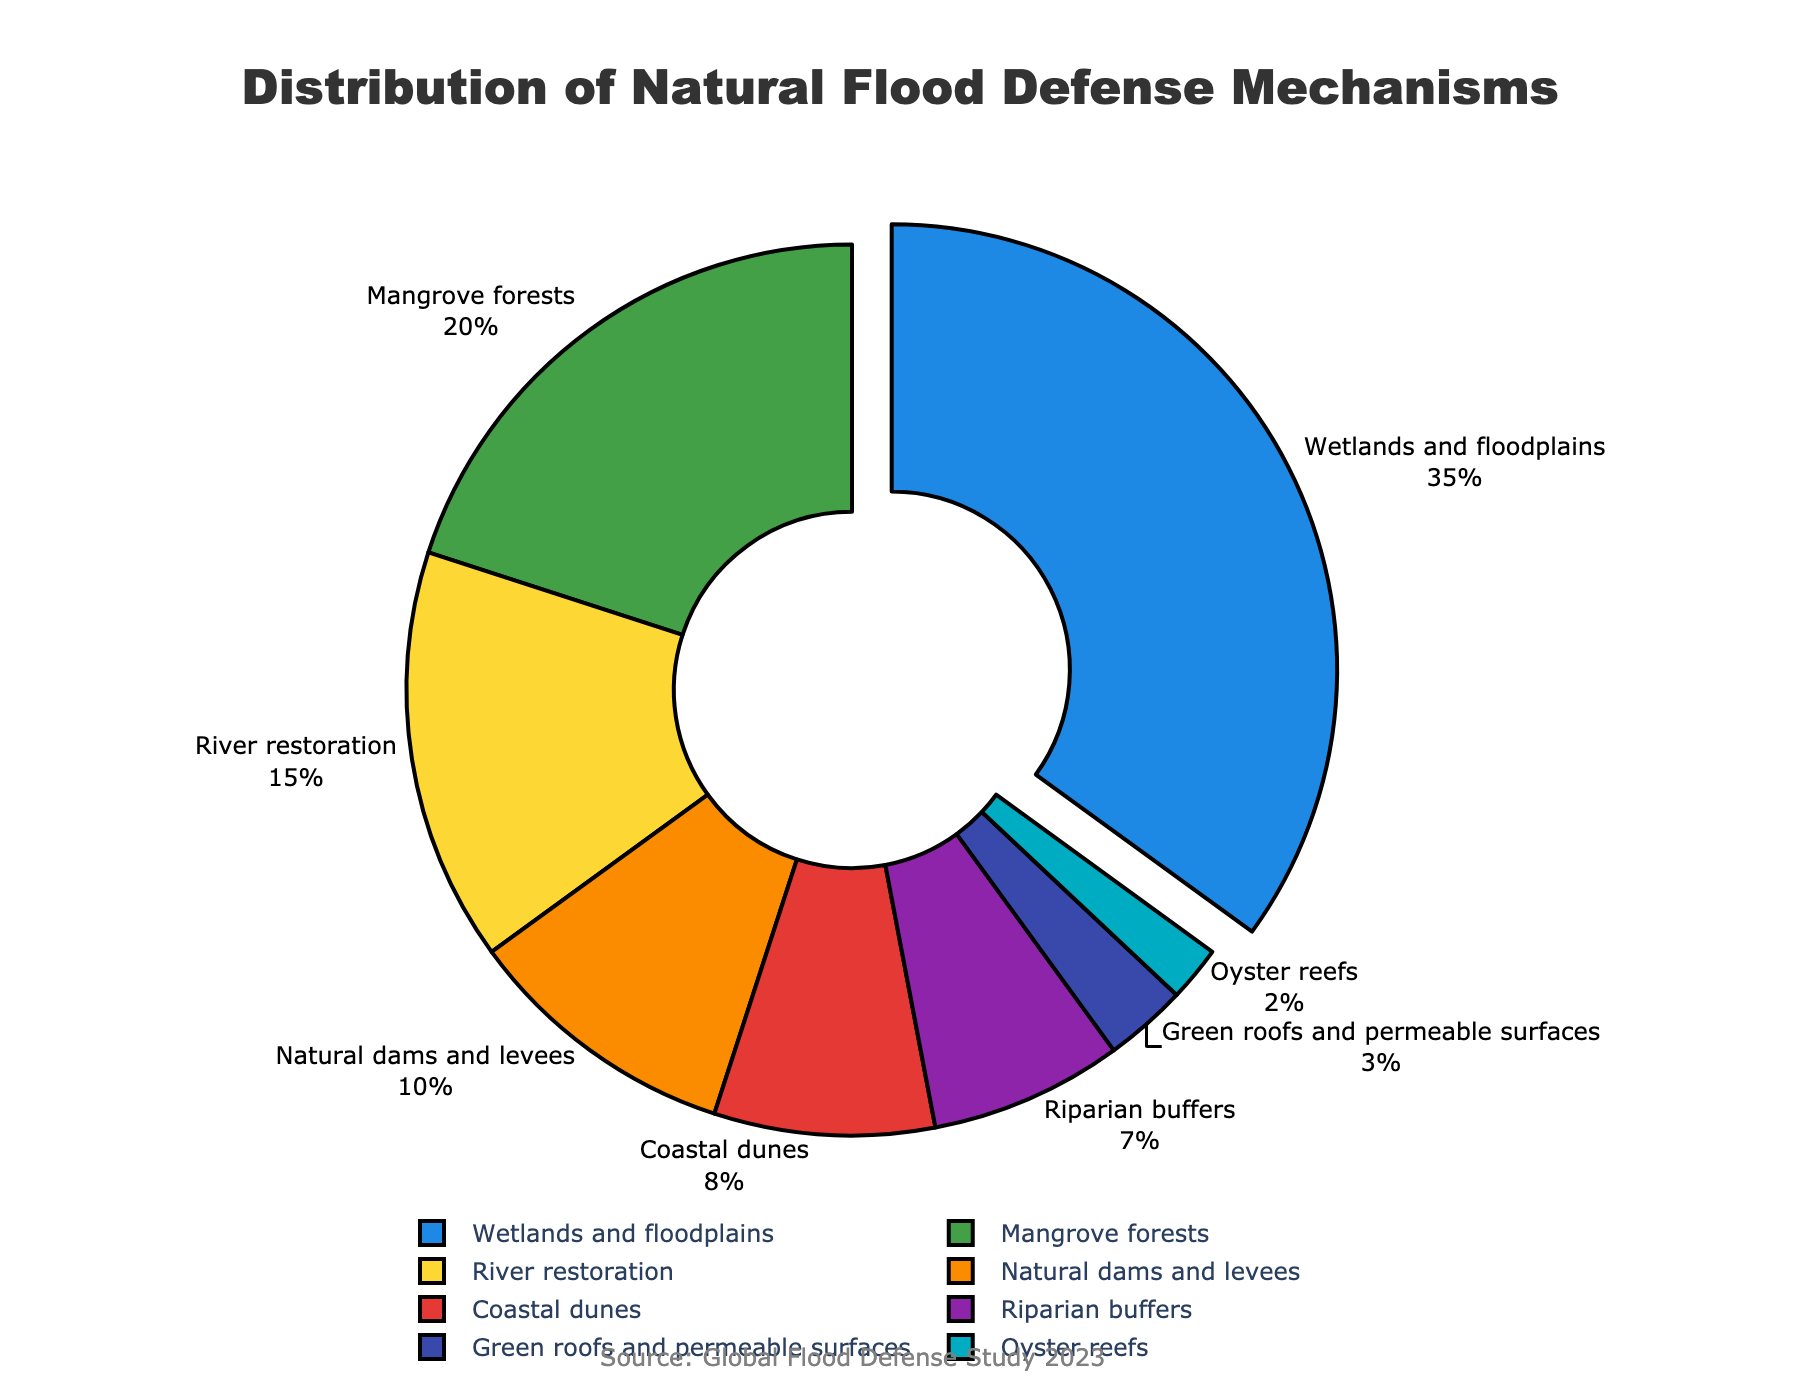Which natural flood defense mechanism is the most commonly used globally? The figure indicates the distribution of various natural flood defense mechanisms. By observing the largest segment in the pie chart, we can see that "Wetlands and floodplains" cover the largest proportion at 35%.
Answer: Wetlands and floodplains Which two categories have the closest percentage of usage? By comparing all the segments, the closest percentages are "Natural dams and levees" at 10% and "Coastal dunes" at 8%, showing the least difference.
Answer: Natural dams and levees and Coastal dunes What is the combined percentage of Mangrove forests, River restoration, and Oyster reefs? Adding the individual percentages of Mangrove forests (20%), River restoration (15%), and Oyster reefs (2%) results in a total: 20 + 15 + 2 = 37%.
Answer: 37% How much more prevalent are Riparian buffers compared to Green roofs and permeable surfaces? Subtract the percentage of Green roofs and permeable surfaces (3%) from Riparian buffers (7%): 7 - 3 = 4%.
Answer: 4% Which category is represented by the green color? From the visual characteristics of the pie chart, the segment colored green corresponds to Mangrove forests at 20%.
Answer: Mangrove forests How many categories have a percentage share of 10% or more? By examining the pie chart, the categories with 10% or more are: "Wetlands and floodplains" (35%), "Mangrove forests" (20%), "River restoration" (15%), and "Natural dams and levees" (10%).
Answer: Four Compare the combined percentage of Coastal dunes and Riparian buffers with the percentage of River restoration. Which is greater and by how much? First, sum the percentages of Coastal dunes (8%) and Riparian buffers (7%), resulting in 15%. As River restoration also has a 15% share, they are equal in percentage.
Answer: Equal Which category has the smallest percentage share? Observing the pie chart, "Oyster reefs" has the smallest visible segment, marked at 2%.
Answer: Oyster reefs What's the total percentage of the top three natural flood defense mechanisms? Adding the percentages of the top three categories: "Wetlands and floodplains" (35%), "Mangrove forests" (20%), and "River restoration" (15%) results in 35 + 20 + 15 = 70%.
Answer: 70% Which categories have a combined share of less than 10%? The categories whose individual shares are less than 10% need to be identified: Green roofs and permeable surfaces (3%) and Oyster reefs (2%). Their combined share is less: 3 + 2 = 5%.
Answer: Green roofs and permeable surfaces and Oyster reefs 